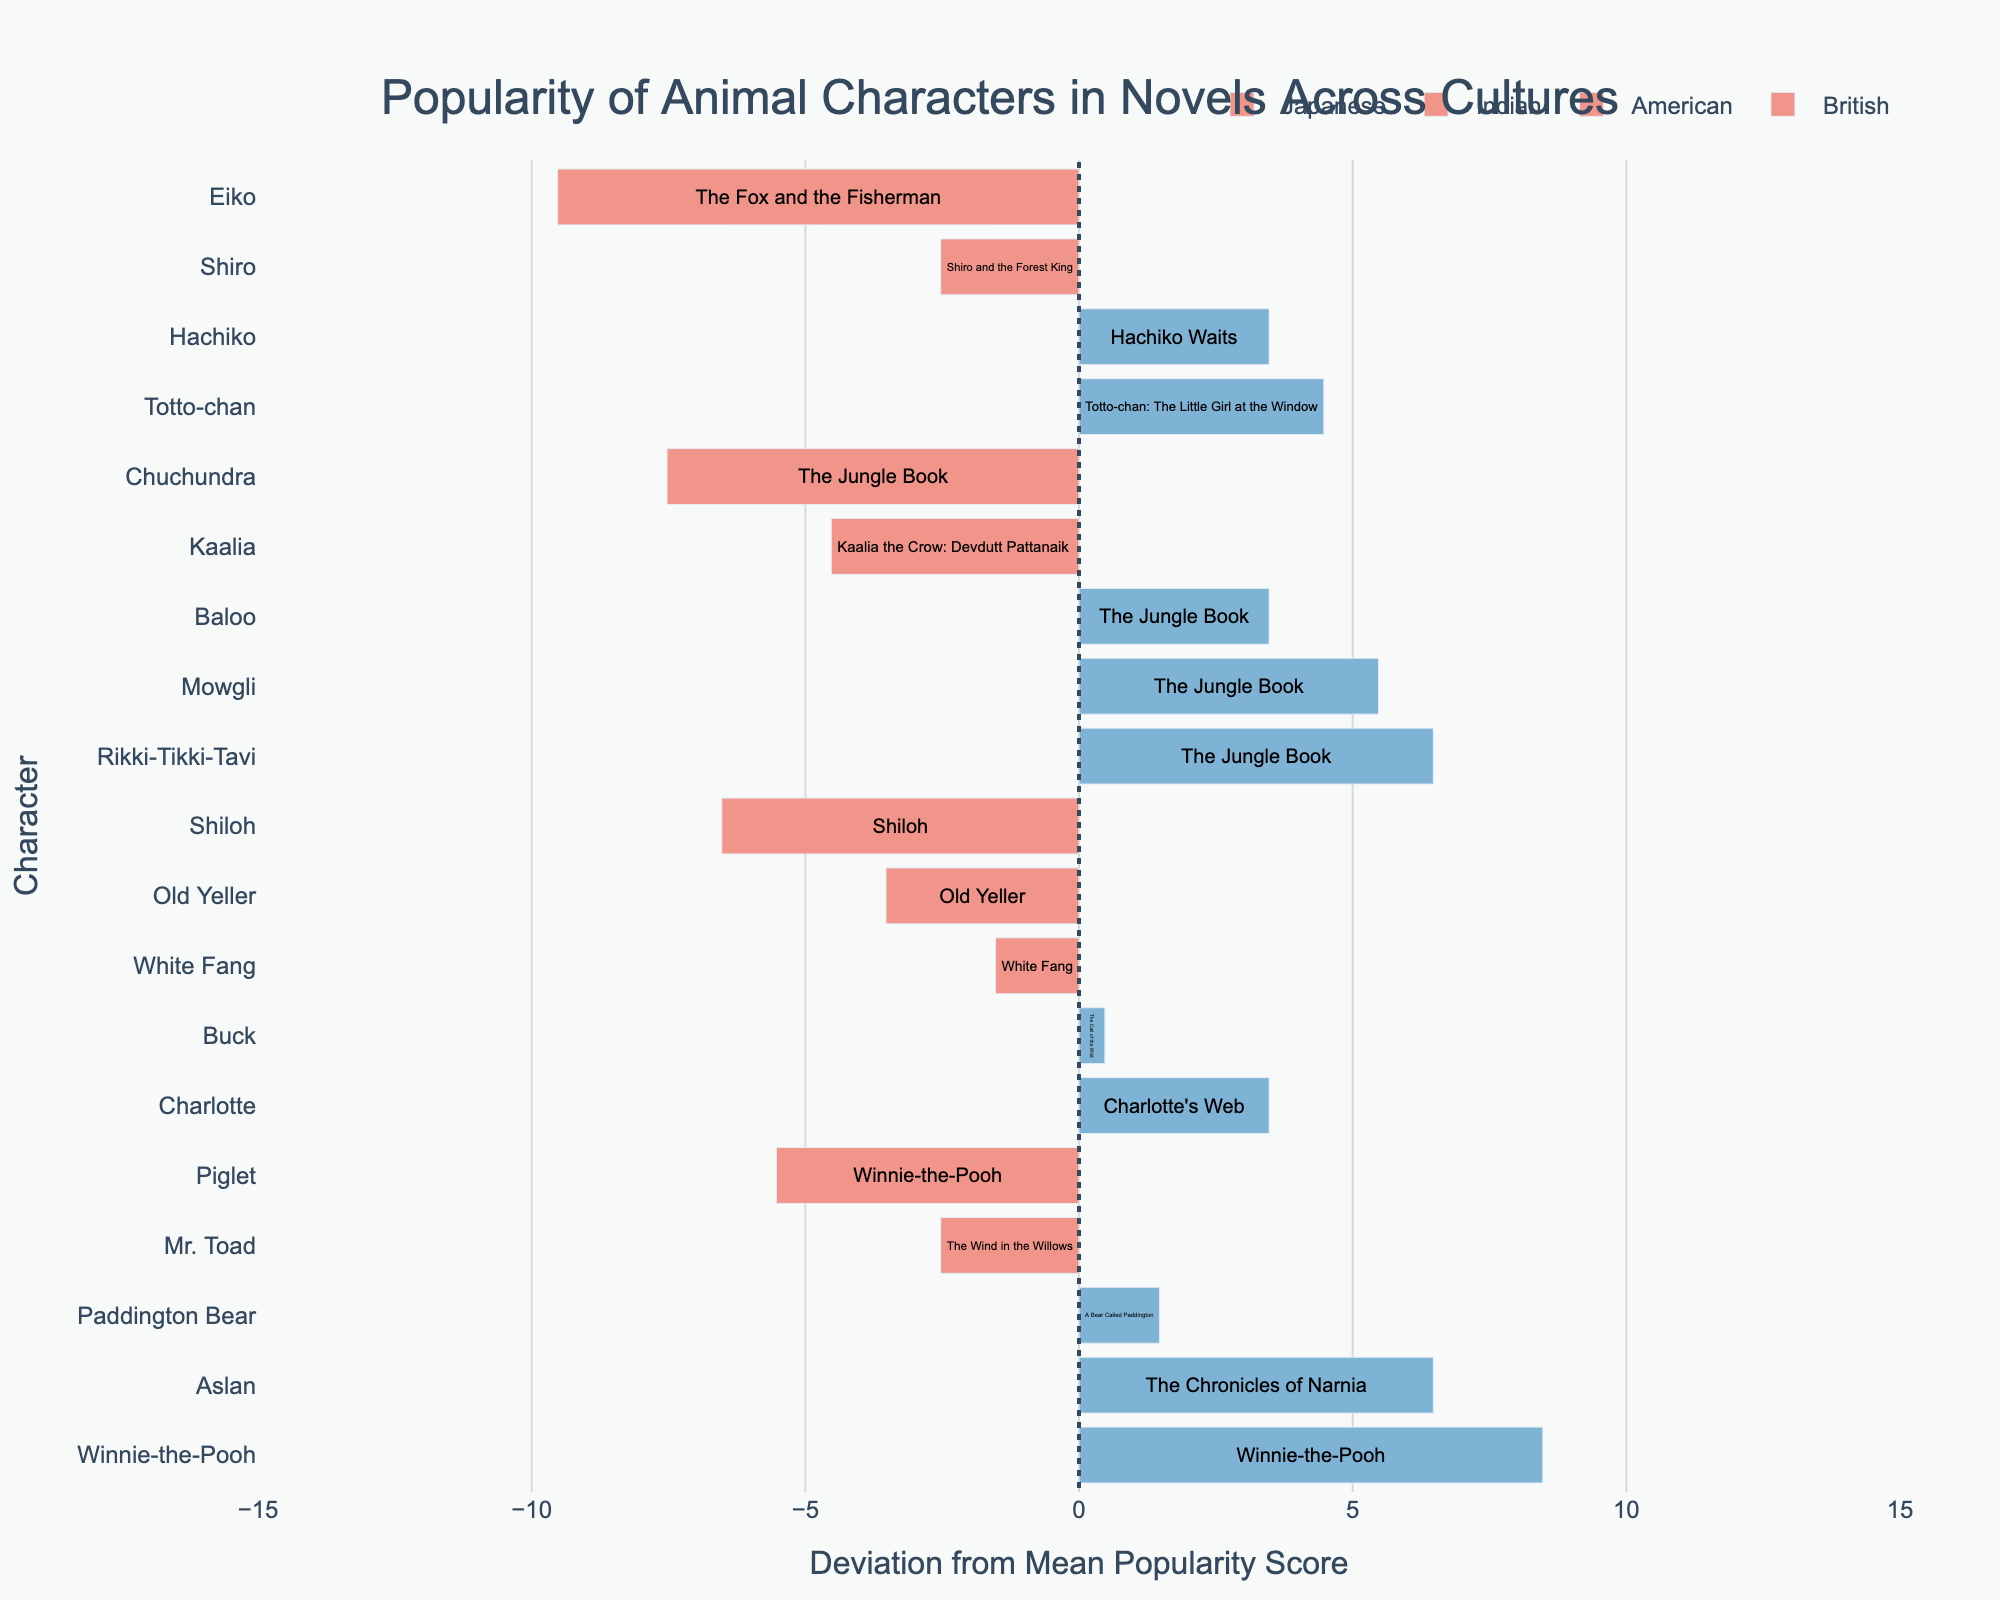Which British character has the highest popularity score? Observe the chart to identify the British character with the bar extending furthest to the right. 'Winnie-the-Pooh' has the highest popularity score among the British characters.
Answer: Winnie-the-Pooh Which Japanese character deviates the most positively from the mean score? Check the Japanese characters and find the one whose bar extends the furthest to the right of the vertical line at x=0. 'Totto-chan' has the largest positive deviation from the mean score.
Answer: Totto-chan What is the mean popularity score used in the chart? Identify bars that cross the x-axis (vertical line at x=0). The mean score is the baseline from which deviations are measured. By definition, 80 marks the center.
Answer: 80 How do American animal characters compare to Indian animal characters in terms of popularity scores above the mean? Look for the American and Indian characters whose bars extend to the right of x=0. Compare their bar lengths for bars extending to the right. American characters include Charlotte, Old Yeller, Buck, White Fang, Shiloh. Indian characters include Rikki-Tikki-Tavi, Baloo, Mowgli. Both sets have characters scoring above the mean, with some differences in the bar lengths.
Answer: Both cultures have characters scoring above the mean, but British characters tend to have more tightly clustered high scores How many characters have scores below the mean popularity score? Count the bars extending to the left of the vertical line at x=0. These bars indicate scores below 80. There are five characters: Shiloh, Piglet, Eiko, Kaalia, Chuchundra.
Answer: 5 Which novel has the highest overall popularity score? Observe the character with the furthest right-extending bar. The associated novel for this character will have the highest score. 'Winnie-the-Pooh' with character 'Winnie-the-Pooh' is highest.
Answer: Winnie-the-Pooh Which American character has the lowest popularity score? Look at the American characters and identify the one with the bar extending furthest to the left of the vertical line at x=0. 'Shiloh' has the lowest popularity score among American characters.
Answer: Shiloh 